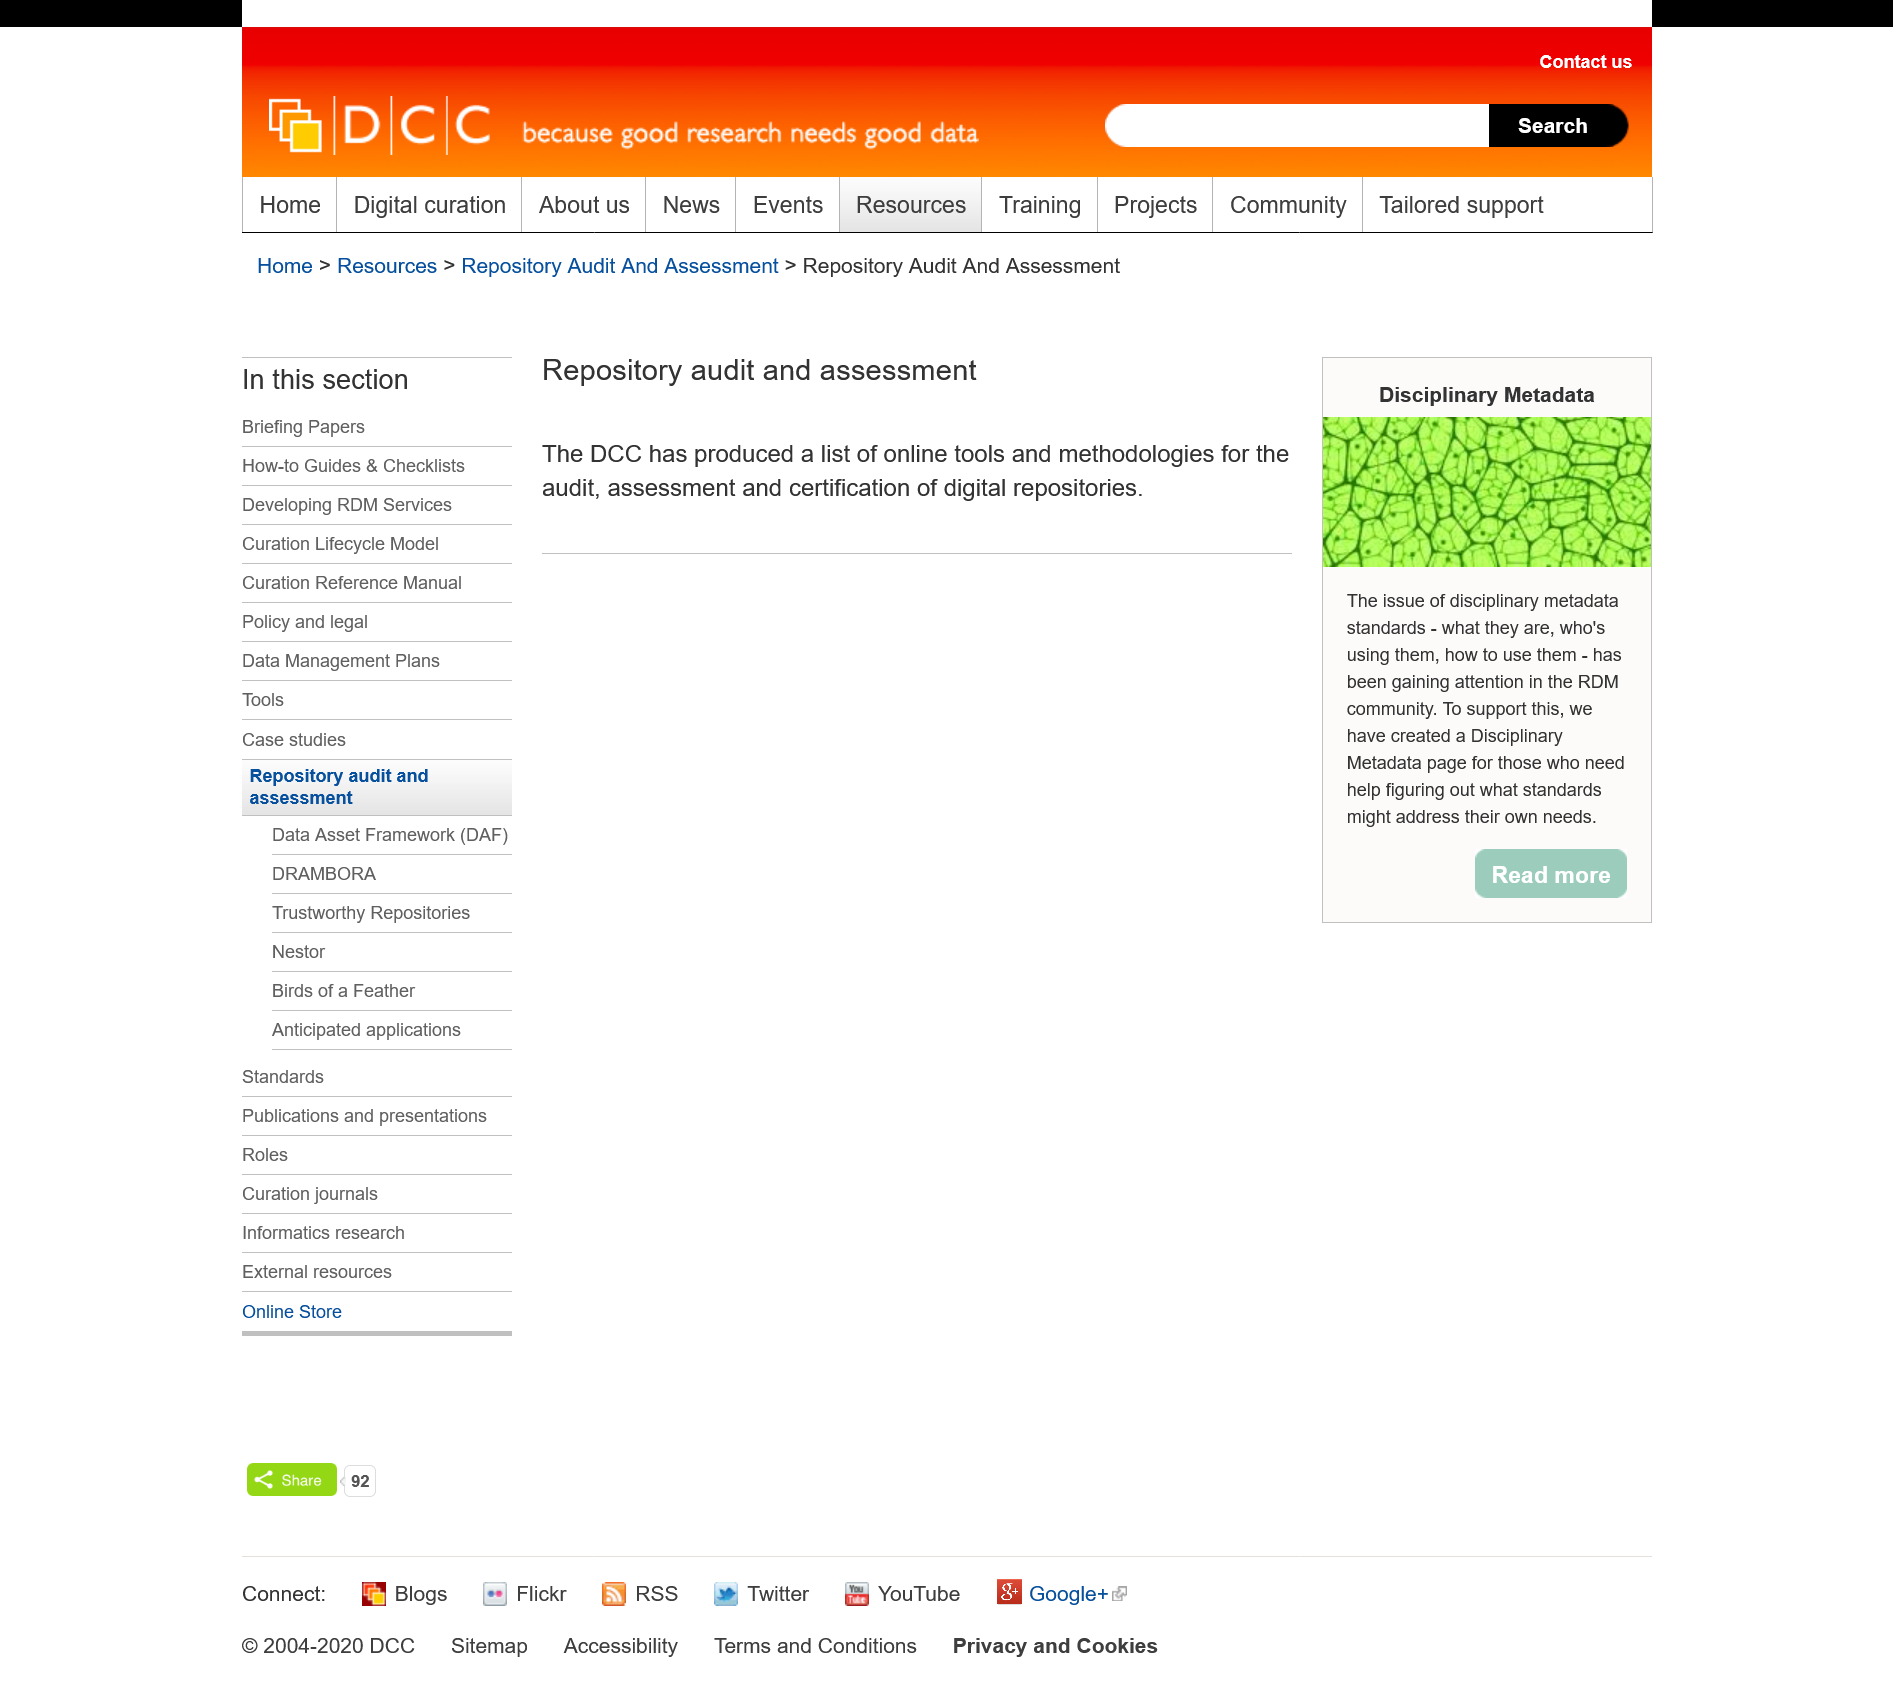Give some essential details in this illustration. This page is about the subject of disciplinary metadata. There is a disciplinary metadata page that can be found. The title of this page is "Disciplinary Metadata". 